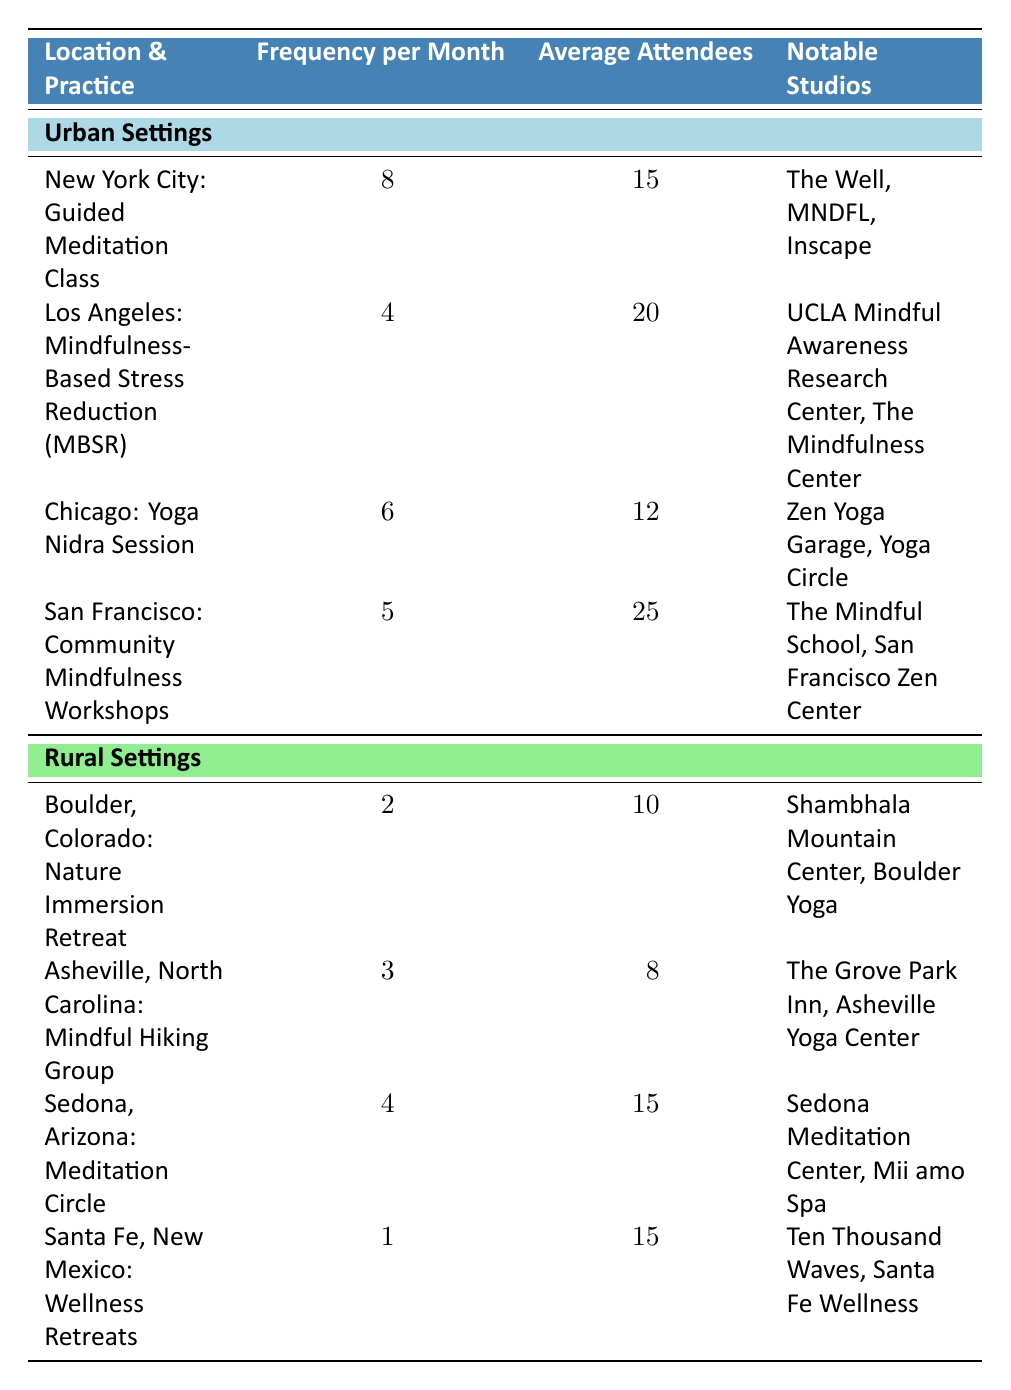What is the frequency of Guided Meditation Classes in New York City? According to the table, the frequency of Guided Meditation Classes in New York City is specifically stated in the row for this practice. The frequency per month is listed as 8.
Answer: 8 Which urban location has the highest average number of attendees? By comparing the average attendees across the urban locations, we can see that San Francisco has 25 average attendees, which is higher than New York City (15), Los Angeles (20), and Chicago (12).
Answer: San Francisco What is the average frequency of mindfulness practices in rural settings? The frequencies for rural settings are 2 (Boulder), 3 (Asheville), 4 (Sedona), and 1 (Santa Fe). Summing them gives 2 + 3 + 4 + 1 = 10. There are 4 rural settings, so the average is 10 / 4 = 2.5.
Answer: 2.5 Is there a notable studio associated with the Mindful Hiking Group in Asheville? The notable studios for the Mindful Hiking Group in Asheville are listed in the table, and it mentions "The Grove Park Inn" and "Asheville Yoga Center." Therefore, there is a notable studio.
Answer: Yes What is the difference in frequency between the highest and lowest mindfulness practice across both settings? The highest frequency is 8 (Guided Meditation Class in New York City) and the lowest is 1 (Wellness Retreats in Santa Fe). The difference is 8 - 1 = 7.
Answer: 7 What practice has the most average attendees in urban settings? To determine this, we refer to the average attendees column for urban settings: New York City has 15, Los Angeles has 20, Chicago has 12, and San Francisco has 25. The highest average attendees are in San Francisco with 25.
Answer: San Francisco: Community Mindfulness Workshops What is the frequency of practices in Boulder compared to practices in Sedona? The frequency of practices in Boulder (Nature Immersion Retreat) is 2, while in Sedona (Meditation Circle) it is 4. When comparing, 4 (Sedona) is greater than 2 (Boulder).
Answer: Sedona has a higher frequency Which urban practice has a frequency that is exactly double the frequency of the Wellness Retreats in Santa Fe? The frequency of the Wellness Retreats in Santa Fe is 1. The only urban practice that has a frequency of 2 (twice 1) is the Nature Immersion Retreat in Boulder, but it is not urban. So, there is no urban practice with a frequency exactly double that of Santa Fe's wellness retreats.
Answer: No urban practice meets this condition 